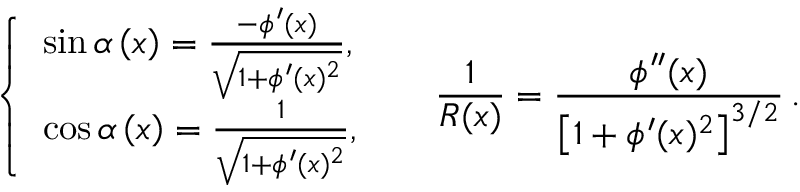<formula> <loc_0><loc_0><loc_500><loc_500>\left \{ { \begin{array} { l } { \sin \alpha \left ( x \right ) = \frac { - \phi ^ { \prime } ( x ) } { \sqrt { 1 + \phi ^ { \prime } ( x ) ^ { 2 } } } , } \\ { \cos \alpha \left ( x \right ) = \frac { 1 } { \sqrt { 1 + \phi ^ { \prime } ( x ) ^ { 2 } } } , } \end{array} } \, \quad \, \frac { 1 } { R ( x ) } = \frac { \phi ^ { \prime \prime } ( x ) } { \left [ { 1 + \phi ^ { \prime } ( x ) ^ { 2 } } \right ] ^ { 3 / 2 } } \, .</formula> 